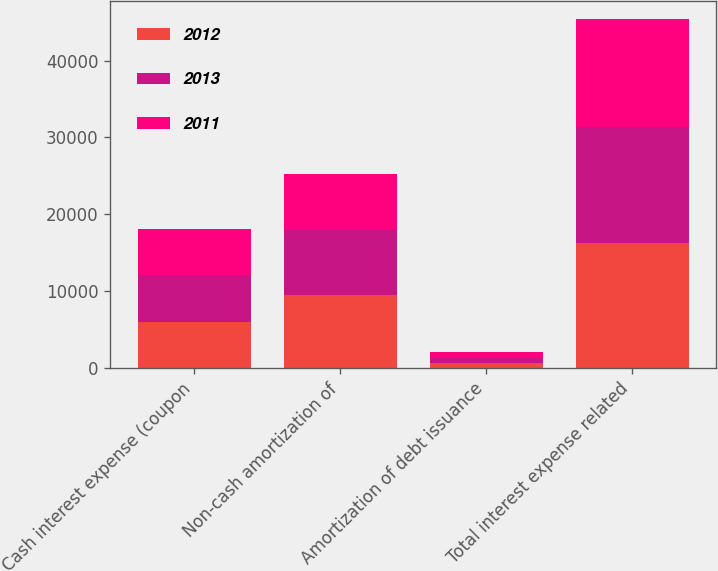Convert chart to OTSL. <chart><loc_0><loc_0><loc_500><loc_500><stacked_bar_chart><ecel><fcel>Cash interest expense (coupon<fcel>Non-cash amortization of<fcel>Amortization of debt issuance<fcel>Total interest expense related<nl><fcel>2012<fcel>6038<fcel>9550<fcel>682<fcel>16270<nl><fcel>2013<fcel>6038<fcel>8392<fcel>682<fcel>15112<nl><fcel>2011<fcel>6004<fcel>7374<fcel>682<fcel>14060<nl></chart> 